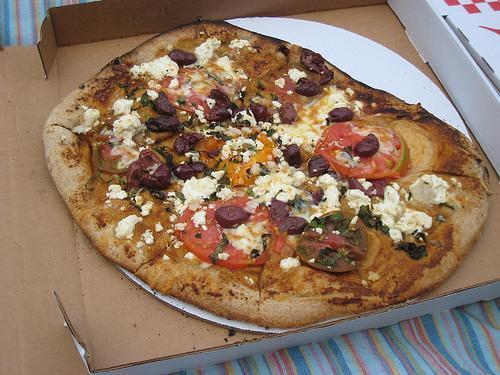How many pizzas are there?
Give a very brief answer. 1. 